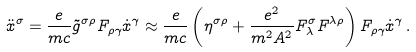Convert formula to latex. <formula><loc_0><loc_0><loc_500><loc_500>\ddot { x } ^ { \sigma } = \frac { e } { m c } \tilde { g } ^ { \sigma \rho } F _ { \rho \gamma } \dot { x } ^ { \gamma } \approx \frac { e } { m c } \left ( \eta ^ { \sigma \rho } + \frac { e ^ { 2 } } { m ^ { 2 } A ^ { 2 } } F ^ { \sigma } _ { \lambda } F ^ { \lambda \rho } \right ) F _ { \rho \gamma } \dot { x } ^ { \gamma } \, { . }</formula> 